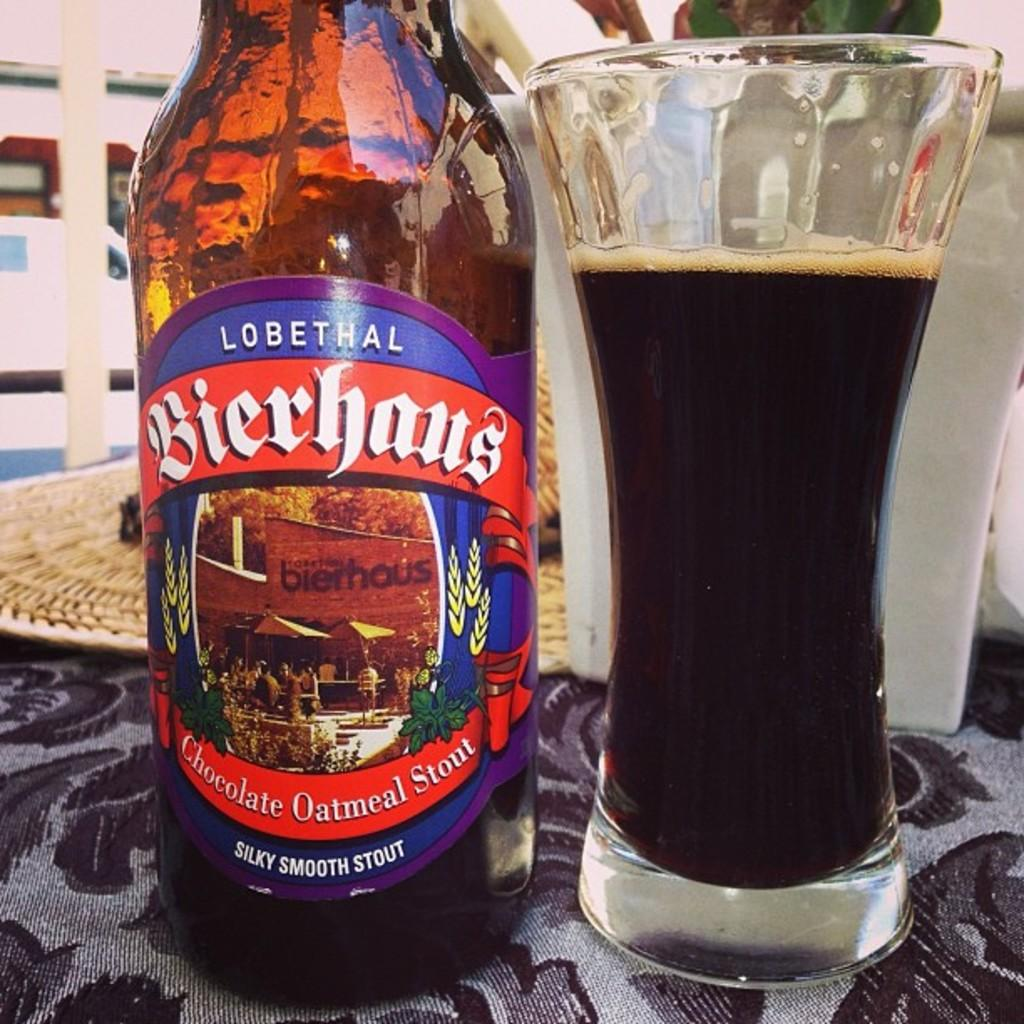<image>
Relay a brief, clear account of the picture shown. According to its label, a bottle of beer has a flavor of chocolate oatmeal stout. 